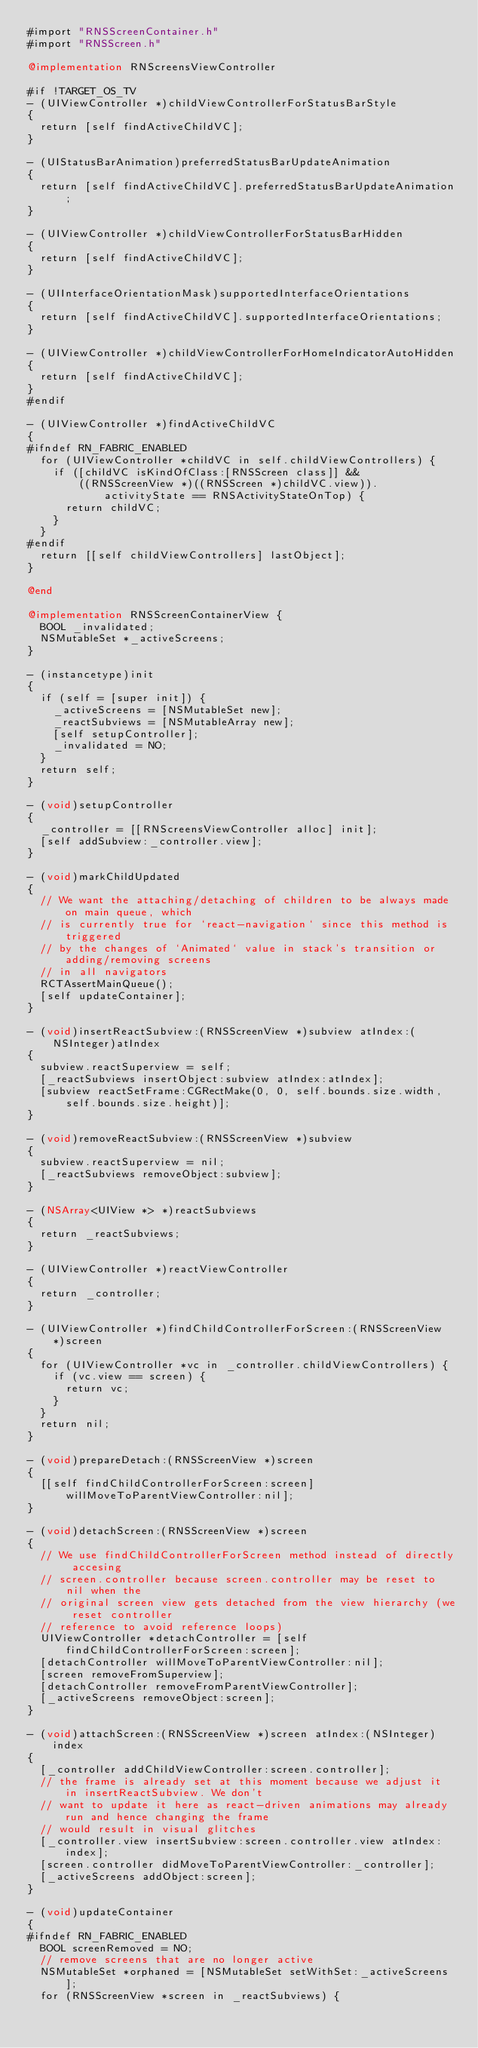Convert code to text. <code><loc_0><loc_0><loc_500><loc_500><_ObjectiveC_>#import "RNSScreenContainer.h"
#import "RNSScreen.h"

@implementation RNScreensViewController

#if !TARGET_OS_TV
- (UIViewController *)childViewControllerForStatusBarStyle
{
  return [self findActiveChildVC];
}

- (UIStatusBarAnimation)preferredStatusBarUpdateAnimation
{
  return [self findActiveChildVC].preferredStatusBarUpdateAnimation;
}

- (UIViewController *)childViewControllerForStatusBarHidden
{
  return [self findActiveChildVC];
}

- (UIInterfaceOrientationMask)supportedInterfaceOrientations
{
  return [self findActiveChildVC].supportedInterfaceOrientations;
}

- (UIViewController *)childViewControllerForHomeIndicatorAutoHidden
{
  return [self findActiveChildVC];
}
#endif

- (UIViewController *)findActiveChildVC
{
#ifndef RN_FABRIC_ENABLED
  for (UIViewController *childVC in self.childViewControllers) {
    if ([childVC isKindOfClass:[RNSScreen class]] &&
        ((RNSScreenView *)((RNSScreen *)childVC.view)).activityState == RNSActivityStateOnTop) {
      return childVC;
    }
  }
#endif
  return [[self childViewControllers] lastObject];
}

@end

@implementation RNSScreenContainerView {
  BOOL _invalidated;
  NSMutableSet *_activeScreens;
}

- (instancetype)init
{
  if (self = [super init]) {
    _activeScreens = [NSMutableSet new];
    _reactSubviews = [NSMutableArray new];
    [self setupController];
    _invalidated = NO;
  }
  return self;
}

- (void)setupController
{
  _controller = [[RNScreensViewController alloc] init];
  [self addSubview:_controller.view];
}

- (void)markChildUpdated
{
  // We want the attaching/detaching of children to be always made on main queue, which
  // is currently true for `react-navigation` since this method is triggered
  // by the changes of `Animated` value in stack's transition or adding/removing screens
  // in all navigators
  RCTAssertMainQueue();
  [self updateContainer];
}

- (void)insertReactSubview:(RNSScreenView *)subview atIndex:(NSInteger)atIndex
{
  subview.reactSuperview = self;
  [_reactSubviews insertObject:subview atIndex:atIndex];
  [subview reactSetFrame:CGRectMake(0, 0, self.bounds.size.width, self.bounds.size.height)];
}

- (void)removeReactSubview:(RNSScreenView *)subview
{
  subview.reactSuperview = nil;
  [_reactSubviews removeObject:subview];
}

- (NSArray<UIView *> *)reactSubviews
{
  return _reactSubviews;
}

- (UIViewController *)reactViewController
{
  return _controller;
}

- (UIViewController *)findChildControllerForScreen:(RNSScreenView *)screen
{
  for (UIViewController *vc in _controller.childViewControllers) {
    if (vc.view == screen) {
      return vc;
    }
  }
  return nil;
}

- (void)prepareDetach:(RNSScreenView *)screen
{
  [[self findChildControllerForScreen:screen] willMoveToParentViewController:nil];
}

- (void)detachScreen:(RNSScreenView *)screen
{
  // We use findChildControllerForScreen method instead of directly accesing
  // screen.controller because screen.controller may be reset to nil when the
  // original screen view gets detached from the view hierarchy (we reset controller
  // reference to avoid reference loops)
  UIViewController *detachController = [self findChildControllerForScreen:screen];
  [detachController willMoveToParentViewController:nil];
  [screen removeFromSuperview];
  [detachController removeFromParentViewController];
  [_activeScreens removeObject:screen];
}

- (void)attachScreen:(RNSScreenView *)screen atIndex:(NSInteger)index
{
  [_controller addChildViewController:screen.controller];
  // the frame is already set at this moment because we adjust it in insertReactSubview. We don't
  // want to update it here as react-driven animations may already run and hence changing the frame
  // would result in visual glitches
  [_controller.view insertSubview:screen.controller.view atIndex:index];
  [screen.controller didMoveToParentViewController:_controller];
  [_activeScreens addObject:screen];
}

- (void)updateContainer
{
#ifndef RN_FABRIC_ENABLED
  BOOL screenRemoved = NO;
  // remove screens that are no longer active
  NSMutableSet *orphaned = [NSMutableSet setWithSet:_activeScreens];
  for (RNSScreenView *screen in _reactSubviews) {</code> 